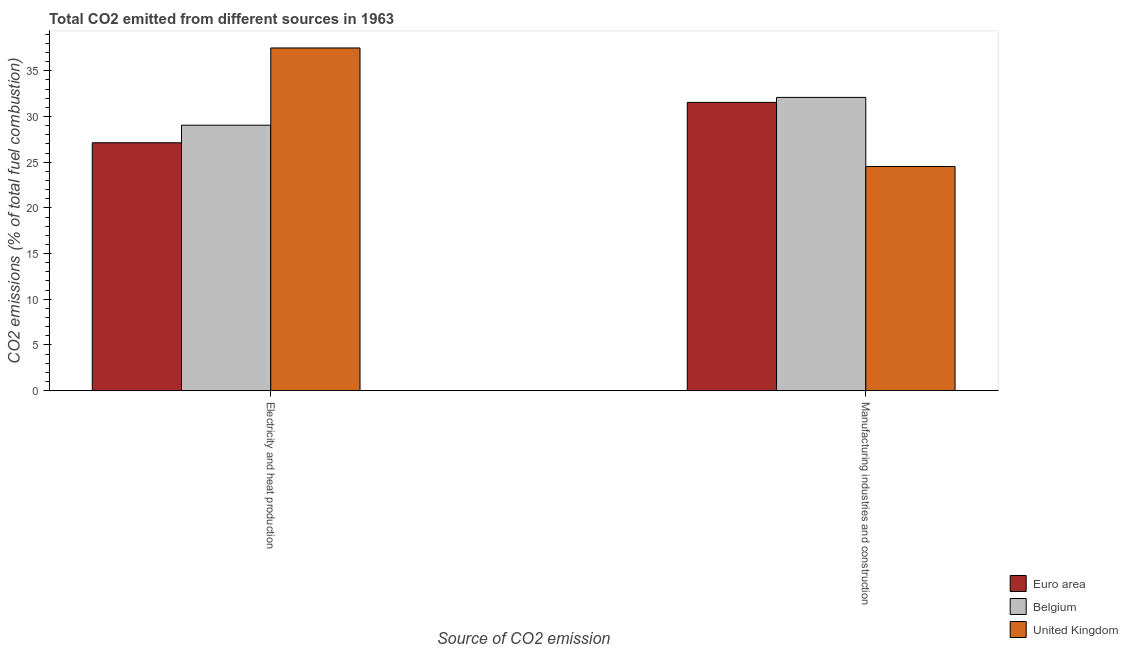How many different coloured bars are there?
Offer a terse response. 3. Are the number of bars per tick equal to the number of legend labels?
Keep it short and to the point. Yes. Are the number of bars on each tick of the X-axis equal?
Offer a very short reply. Yes. How many bars are there on the 2nd tick from the right?
Ensure brevity in your answer.  3. What is the label of the 2nd group of bars from the left?
Your answer should be compact. Manufacturing industries and construction. What is the co2 emissions due to electricity and heat production in United Kingdom?
Make the answer very short. 37.5. Across all countries, what is the maximum co2 emissions due to manufacturing industries?
Offer a very short reply. 32.09. Across all countries, what is the minimum co2 emissions due to electricity and heat production?
Give a very brief answer. 27.13. In which country was the co2 emissions due to manufacturing industries maximum?
Give a very brief answer. Belgium. What is the total co2 emissions due to electricity and heat production in the graph?
Give a very brief answer. 93.67. What is the difference between the co2 emissions due to manufacturing industries in Belgium and that in United Kingdom?
Offer a very short reply. 7.56. What is the difference between the co2 emissions due to manufacturing industries in United Kingdom and the co2 emissions due to electricity and heat production in Euro area?
Provide a short and direct response. -2.6. What is the average co2 emissions due to manufacturing industries per country?
Give a very brief answer. 29.39. What is the difference between the co2 emissions due to manufacturing industries and co2 emissions due to electricity and heat production in Euro area?
Provide a short and direct response. 4.42. What is the ratio of the co2 emissions due to manufacturing industries in Belgium to that in Euro area?
Offer a terse response. 1.02. In how many countries, is the co2 emissions due to manufacturing industries greater than the average co2 emissions due to manufacturing industries taken over all countries?
Keep it short and to the point. 2. What does the 3rd bar from the left in Electricity and heat production represents?
Offer a very short reply. United Kingdom. What does the 2nd bar from the right in Electricity and heat production represents?
Keep it short and to the point. Belgium. How many countries are there in the graph?
Give a very brief answer. 3. Are the values on the major ticks of Y-axis written in scientific E-notation?
Your answer should be compact. No. How are the legend labels stacked?
Your answer should be compact. Vertical. What is the title of the graph?
Keep it short and to the point. Total CO2 emitted from different sources in 1963. Does "Slovenia" appear as one of the legend labels in the graph?
Give a very brief answer. No. What is the label or title of the X-axis?
Give a very brief answer. Source of CO2 emission. What is the label or title of the Y-axis?
Make the answer very short. CO2 emissions (% of total fuel combustion). What is the CO2 emissions (% of total fuel combustion) in Euro area in Electricity and heat production?
Make the answer very short. 27.13. What is the CO2 emissions (% of total fuel combustion) of Belgium in Electricity and heat production?
Offer a very short reply. 29.05. What is the CO2 emissions (% of total fuel combustion) in United Kingdom in Electricity and heat production?
Ensure brevity in your answer.  37.5. What is the CO2 emissions (% of total fuel combustion) in Euro area in Manufacturing industries and construction?
Give a very brief answer. 31.54. What is the CO2 emissions (% of total fuel combustion) of Belgium in Manufacturing industries and construction?
Ensure brevity in your answer.  32.09. What is the CO2 emissions (% of total fuel combustion) of United Kingdom in Manufacturing industries and construction?
Your response must be concise. 24.53. Across all Source of CO2 emission, what is the maximum CO2 emissions (% of total fuel combustion) of Euro area?
Your answer should be very brief. 31.54. Across all Source of CO2 emission, what is the maximum CO2 emissions (% of total fuel combustion) of Belgium?
Offer a terse response. 32.09. Across all Source of CO2 emission, what is the maximum CO2 emissions (% of total fuel combustion) in United Kingdom?
Your answer should be very brief. 37.5. Across all Source of CO2 emission, what is the minimum CO2 emissions (% of total fuel combustion) of Euro area?
Provide a succinct answer. 27.13. Across all Source of CO2 emission, what is the minimum CO2 emissions (% of total fuel combustion) of Belgium?
Make the answer very short. 29.05. Across all Source of CO2 emission, what is the minimum CO2 emissions (% of total fuel combustion) in United Kingdom?
Give a very brief answer. 24.53. What is the total CO2 emissions (% of total fuel combustion) in Euro area in the graph?
Your response must be concise. 58.67. What is the total CO2 emissions (% of total fuel combustion) of Belgium in the graph?
Offer a terse response. 61.14. What is the total CO2 emissions (% of total fuel combustion) of United Kingdom in the graph?
Provide a short and direct response. 62.03. What is the difference between the CO2 emissions (% of total fuel combustion) in Euro area in Electricity and heat production and that in Manufacturing industries and construction?
Ensure brevity in your answer.  -4.42. What is the difference between the CO2 emissions (% of total fuel combustion) of Belgium in Electricity and heat production and that in Manufacturing industries and construction?
Give a very brief answer. -3.04. What is the difference between the CO2 emissions (% of total fuel combustion) in United Kingdom in Electricity and heat production and that in Manufacturing industries and construction?
Your answer should be compact. 12.97. What is the difference between the CO2 emissions (% of total fuel combustion) in Euro area in Electricity and heat production and the CO2 emissions (% of total fuel combustion) in Belgium in Manufacturing industries and construction?
Your response must be concise. -4.96. What is the difference between the CO2 emissions (% of total fuel combustion) of Euro area in Electricity and heat production and the CO2 emissions (% of total fuel combustion) of United Kingdom in Manufacturing industries and construction?
Keep it short and to the point. 2.6. What is the difference between the CO2 emissions (% of total fuel combustion) of Belgium in Electricity and heat production and the CO2 emissions (% of total fuel combustion) of United Kingdom in Manufacturing industries and construction?
Provide a succinct answer. 4.52. What is the average CO2 emissions (% of total fuel combustion) of Euro area per Source of CO2 emission?
Offer a terse response. 29.33. What is the average CO2 emissions (% of total fuel combustion) in Belgium per Source of CO2 emission?
Offer a terse response. 30.57. What is the average CO2 emissions (% of total fuel combustion) in United Kingdom per Source of CO2 emission?
Make the answer very short. 31.01. What is the difference between the CO2 emissions (% of total fuel combustion) of Euro area and CO2 emissions (% of total fuel combustion) of Belgium in Electricity and heat production?
Give a very brief answer. -1.92. What is the difference between the CO2 emissions (% of total fuel combustion) in Euro area and CO2 emissions (% of total fuel combustion) in United Kingdom in Electricity and heat production?
Your response must be concise. -10.37. What is the difference between the CO2 emissions (% of total fuel combustion) in Belgium and CO2 emissions (% of total fuel combustion) in United Kingdom in Electricity and heat production?
Provide a short and direct response. -8.45. What is the difference between the CO2 emissions (% of total fuel combustion) in Euro area and CO2 emissions (% of total fuel combustion) in Belgium in Manufacturing industries and construction?
Ensure brevity in your answer.  -0.55. What is the difference between the CO2 emissions (% of total fuel combustion) of Euro area and CO2 emissions (% of total fuel combustion) of United Kingdom in Manufacturing industries and construction?
Keep it short and to the point. 7.01. What is the difference between the CO2 emissions (% of total fuel combustion) in Belgium and CO2 emissions (% of total fuel combustion) in United Kingdom in Manufacturing industries and construction?
Give a very brief answer. 7.56. What is the ratio of the CO2 emissions (% of total fuel combustion) of Euro area in Electricity and heat production to that in Manufacturing industries and construction?
Ensure brevity in your answer.  0.86. What is the ratio of the CO2 emissions (% of total fuel combustion) in Belgium in Electricity and heat production to that in Manufacturing industries and construction?
Make the answer very short. 0.91. What is the ratio of the CO2 emissions (% of total fuel combustion) in United Kingdom in Electricity and heat production to that in Manufacturing industries and construction?
Keep it short and to the point. 1.53. What is the difference between the highest and the second highest CO2 emissions (% of total fuel combustion) in Euro area?
Make the answer very short. 4.42. What is the difference between the highest and the second highest CO2 emissions (% of total fuel combustion) of Belgium?
Offer a terse response. 3.04. What is the difference between the highest and the second highest CO2 emissions (% of total fuel combustion) in United Kingdom?
Give a very brief answer. 12.97. What is the difference between the highest and the lowest CO2 emissions (% of total fuel combustion) of Euro area?
Provide a short and direct response. 4.42. What is the difference between the highest and the lowest CO2 emissions (% of total fuel combustion) of Belgium?
Provide a succinct answer. 3.04. What is the difference between the highest and the lowest CO2 emissions (% of total fuel combustion) of United Kingdom?
Make the answer very short. 12.97. 